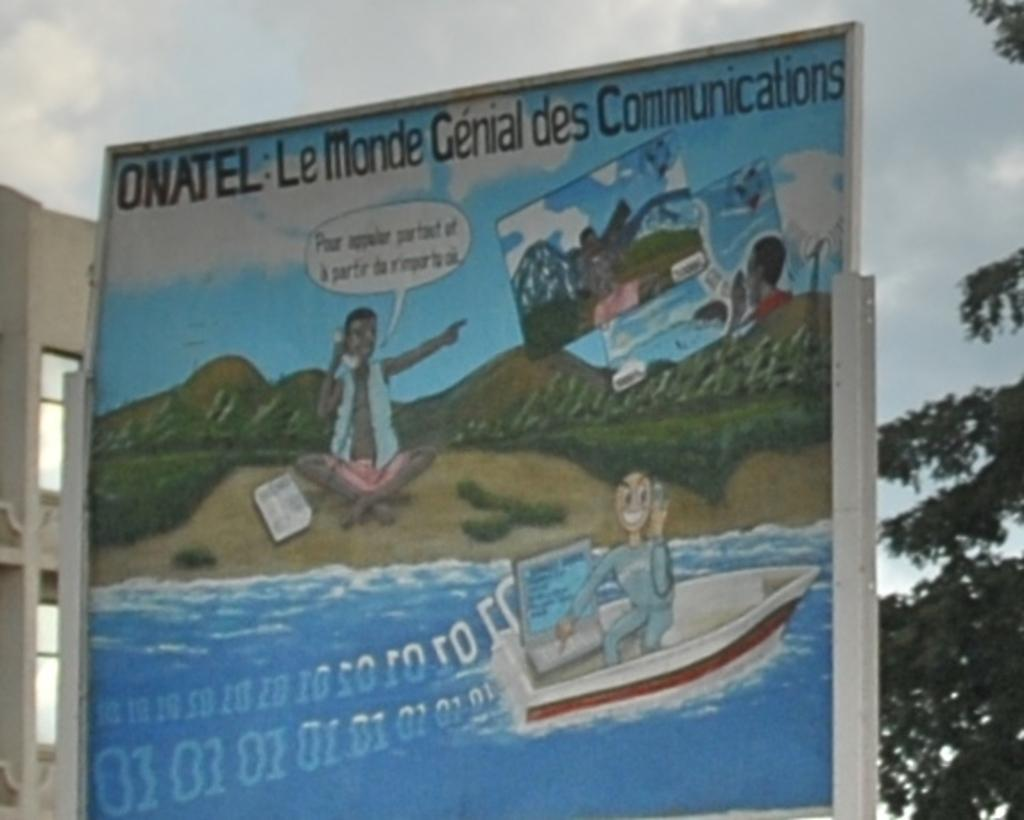<image>
Relay a brief, clear account of the picture shown. A sign advertising ONATEL in French has scene with a boat on a river. 